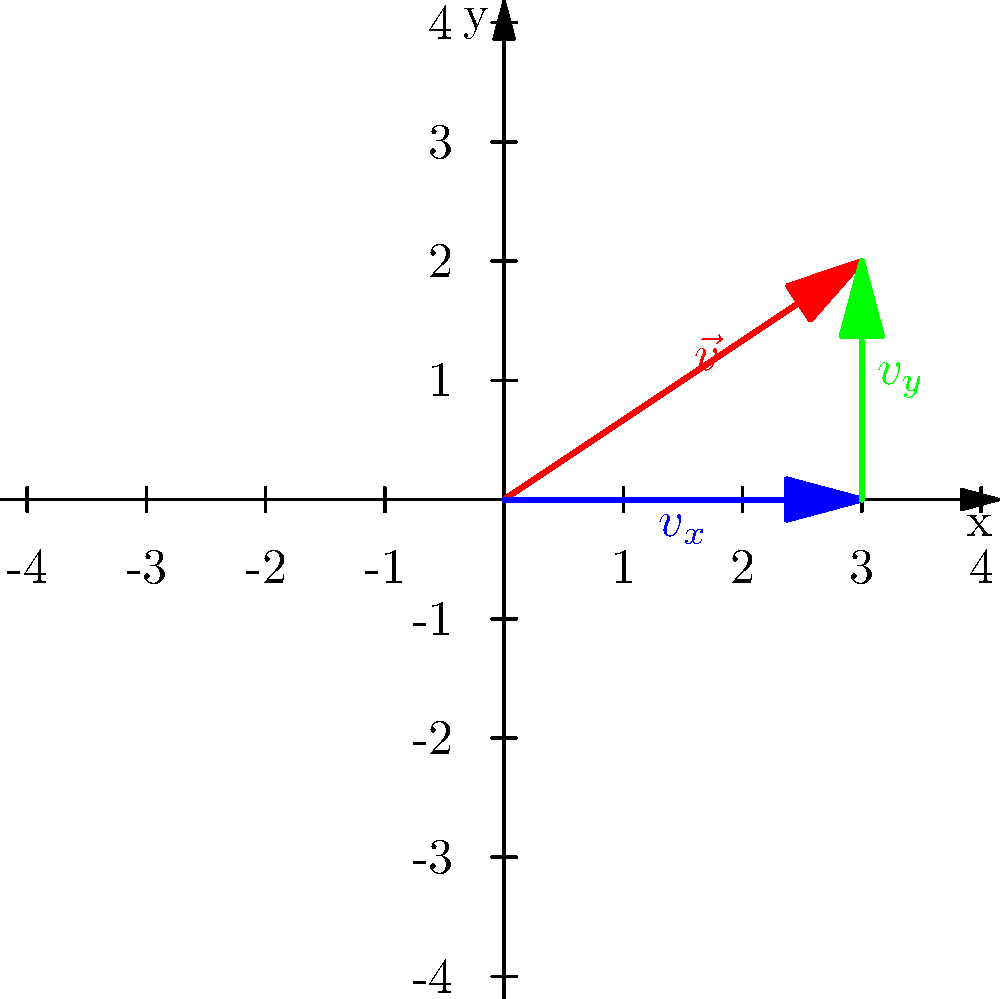In the coordinate grid above, vector $\vec{v}$ is shown in red. What are the x and y components of this vector? Express your answer as an ordered pair $(v_x, v_y)$. To find the components of vector $\vec{v}$, we need to decompose it into its horizontal (x) and vertical (y) components. Let's approach this step-by-step:

1) First, observe that the vector $\vec{v}$ starts at the origin (0,0) and ends at the point (3,2).

2) The x-component ($v_x$) is the horizontal distance the vector covers. This is represented by the blue arrow in the diagram. We can see that it extends from x=0 to x=3.
   Therefore, $v_x = 3$

3) The y-component ($v_y$) is the vertical distance the vector covers. This is represented by the green arrow in the diagram. We can see that it extends from y=0 to y=2.
   Therefore, $v_y = 2$

4) We can verify this visually by seeing that the red vector $\vec{v}$ is indeed the sum of the blue horizontal vector (3 units right) and the green vertical vector (2 units up).

5) The components of a vector are typically written as an ordered pair $(v_x, v_y)$.

Therefore, the components of vector $\vec{v}$ are (3, 2).
Answer: (3, 2) 